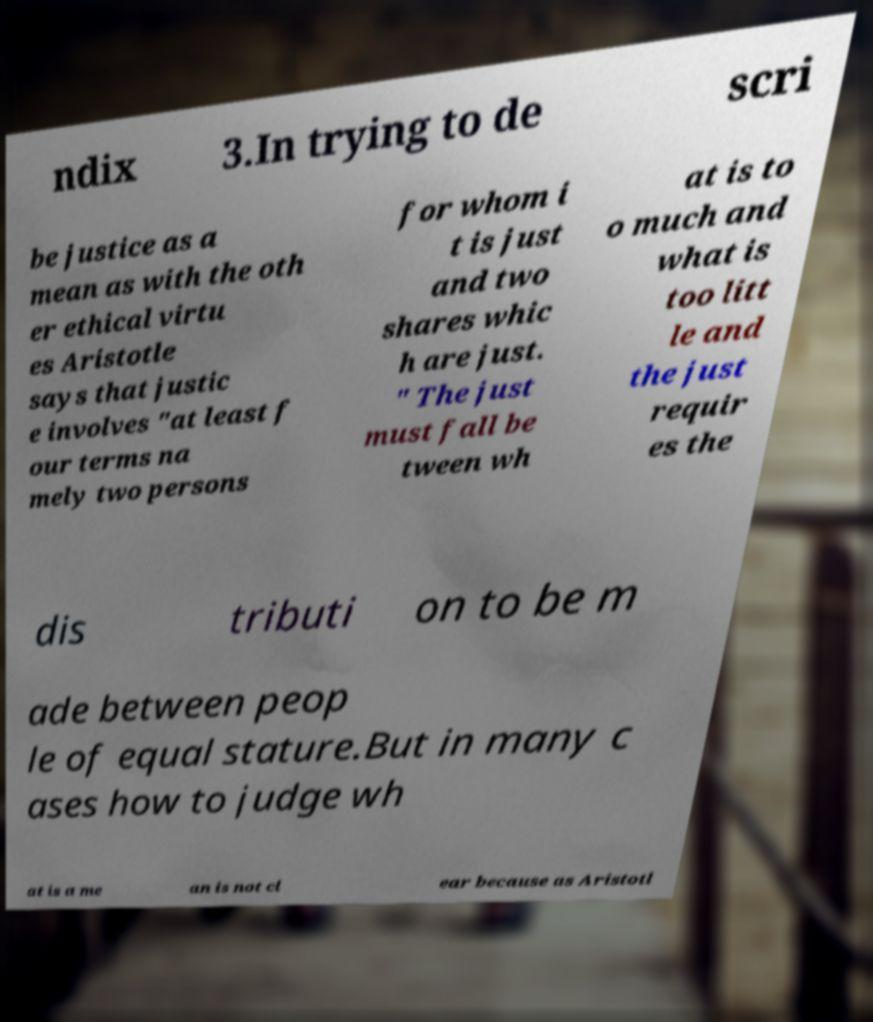What messages or text are displayed in this image? I need them in a readable, typed format. ndix 3.In trying to de scri be justice as a mean as with the oth er ethical virtu es Aristotle says that justic e involves "at least f our terms na mely two persons for whom i t is just and two shares whic h are just. " The just must fall be tween wh at is to o much and what is too litt le and the just requir es the dis tributi on to be m ade between peop le of equal stature.But in many c ases how to judge wh at is a me an is not cl ear because as Aristotl 